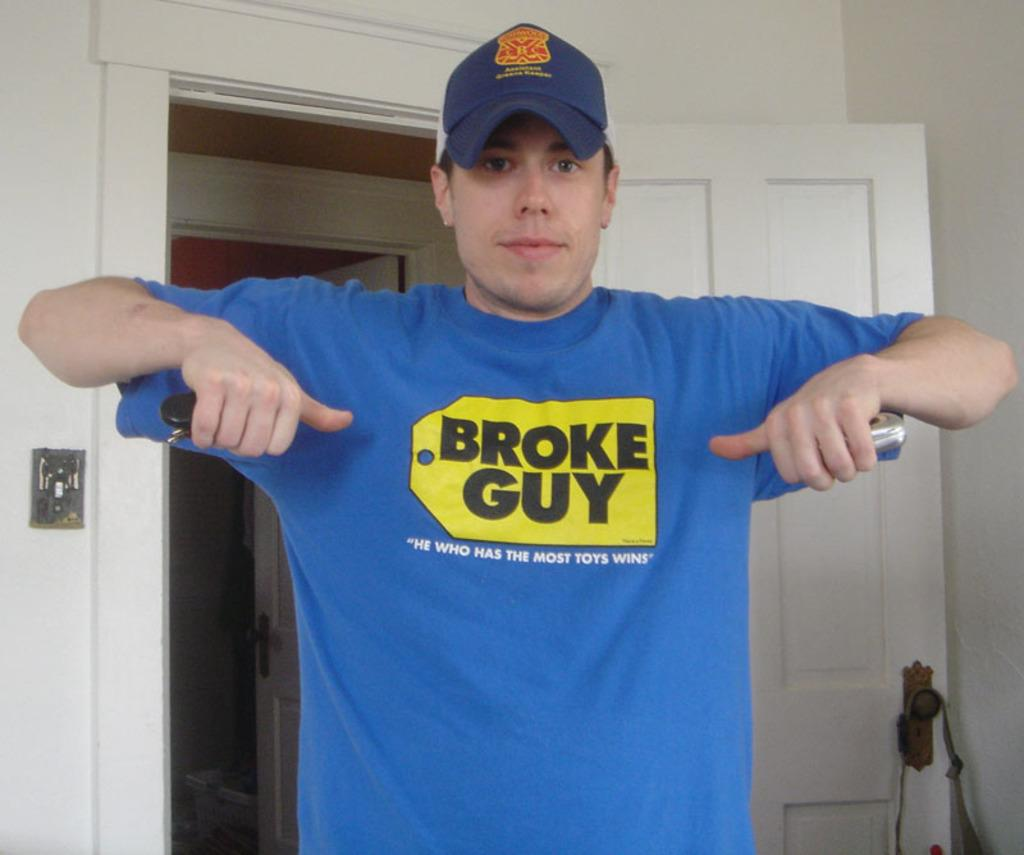<image>
Render a clear and concise summary of the photo. A man pointing at his shirt, the shirt has a yellow tag that says "Broke Guy" printed on it. 